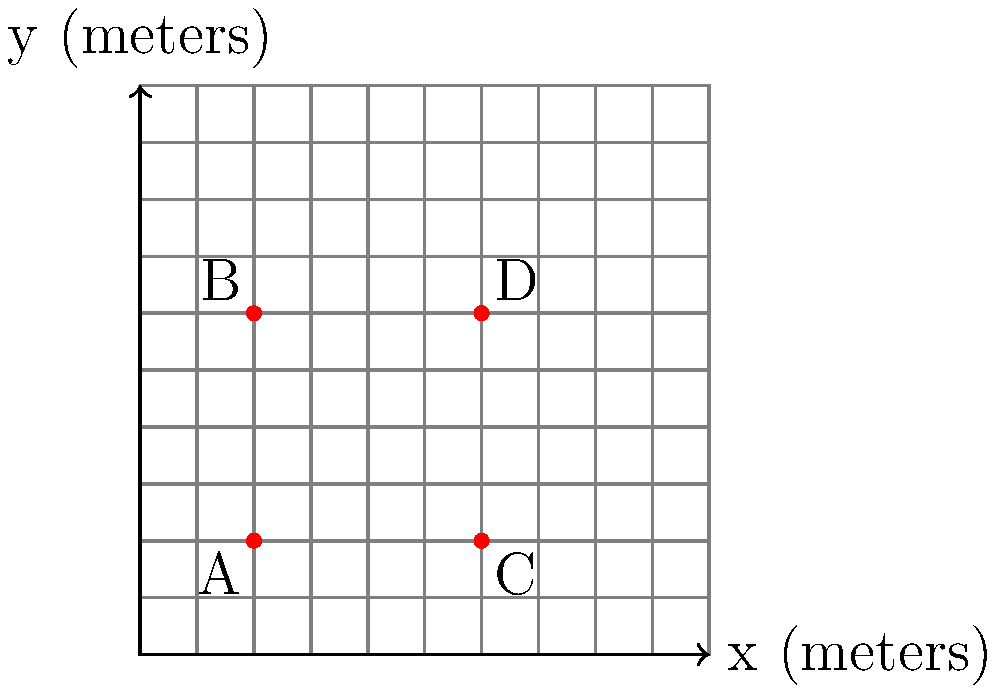In a sustainable garden plot represented by a coordinate grid, four plants (A, B, C, and D) are placed as shown. Each unit on the grid represents 1 meter. To optimize resource usage and plant growth, you need to calculate the average distance between adjacent plants. What is the average distance between adjacent plants in meters, rounded to one decimal place? To solve this problem, we'll follow these steps:

1) Identify adjacent plant pairs: A-B, A-C, B-D, C-D

2) Calculate the distance between each pair using the distance formula:
   $d = \sqrt{(x_2-x_1)^2 + (y_2-y_1)^2}$

3) For A-B:
   $d_{AB} = \sqrt{(2-2)^2 + (6-2)^2} = \sqrt{0^2 + 4^2} = \sqrt{16} = 4$ meters

4) For A-C:
   $d_{AC} = \sqrt{(6-2)^2 + (2-2)^2} = \sqrt{4^2 + 0^2} = \sqrt{16} = 4$ meters

5) For B-D:
   $d_{BD} = \sqrt{(6-2)^2 + (6-6)^2} = \sqrt{4^2 + 0^2} = \sqrt{16} = 4$ meters

6) For C-D:
   $d_{CD} = \sqrt{(6-6)^2 + (6-2)^2} = \sqrt{0^2 + 4^2} = \sqrt{16} = 4$ meters

7) Calculate the average:
   Average distance = $\frac{d_{AB} + d_{AC} + d_{BD} + d_{CD}}{4}$
                    = $\frac{4 + 4 + 4 + 4}{4} = \frac{16}{4} = 4$ meters

8) The average is already a whole number, so rounding to one decimal place gives 4.0 meters.
Answer: 4.0 meters 